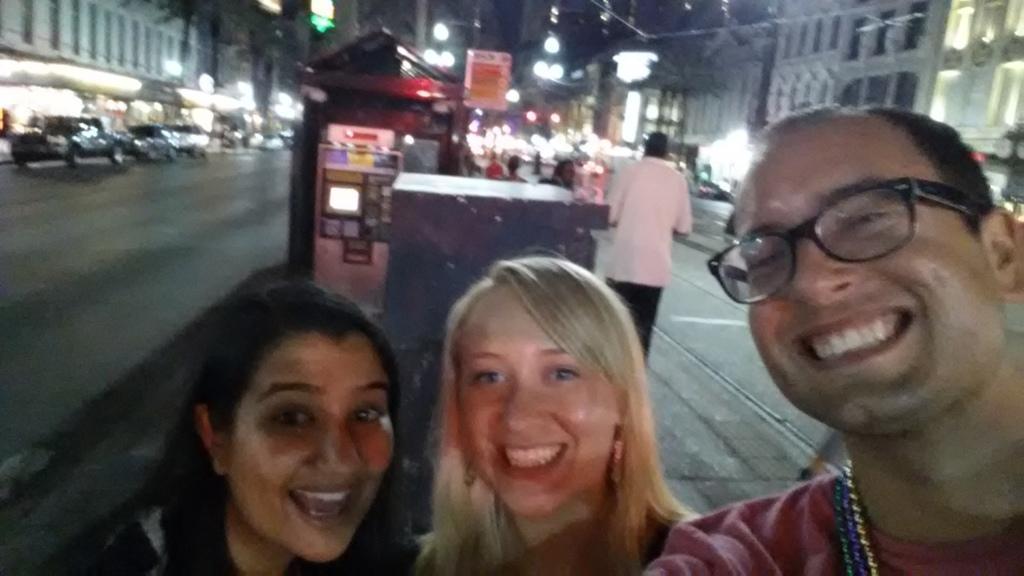Can you describe this image briefly? There is a main road and in between the road there is a divisor and three people are standing on that and taking a selfie,behind them there are many vehicles moving on the road and around the road there are plenty of buildings and stores. 